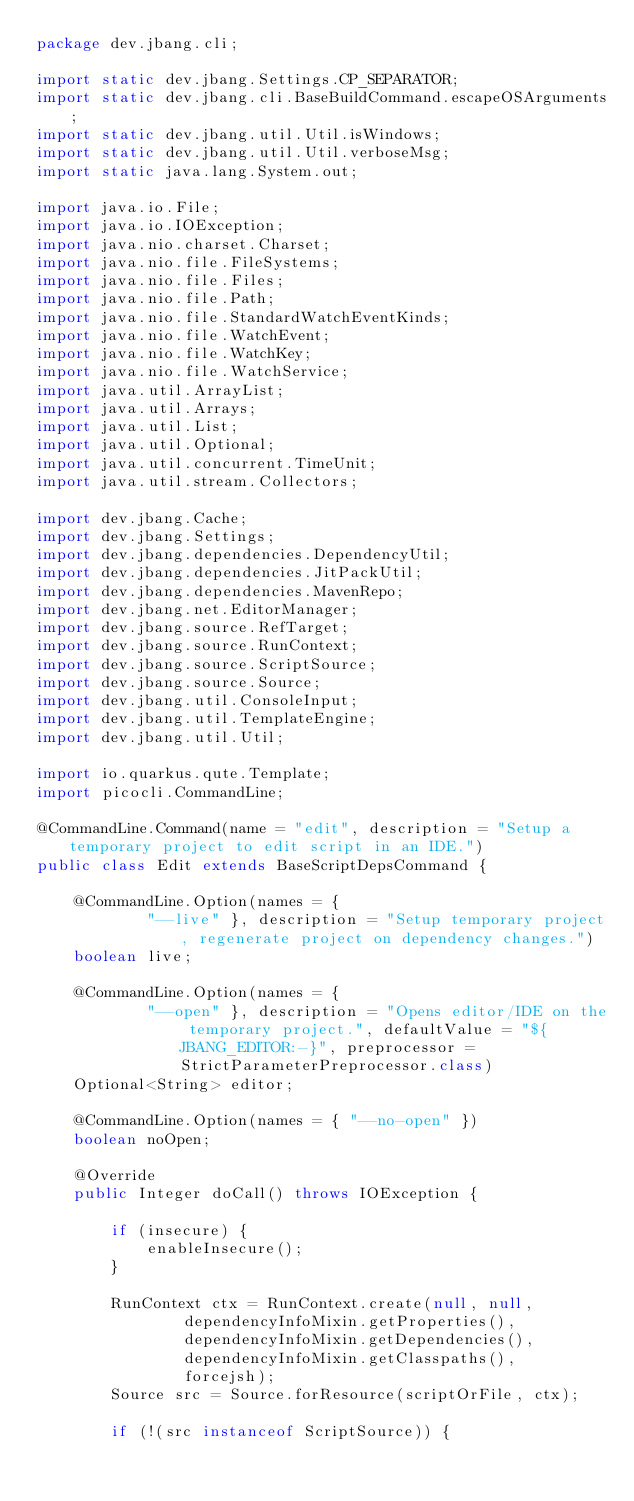Convert code to text. <code><loc_0><loc_0><loc_500><loc_500><_Java_>package dev.jbang.cli;

import static dev.jbang.Settings.CP_SEPARATOR;
import static dev.jbang.cli.BaseBuildCommand.escapeOSArguments;
import static dev.jbang.util.Util.isWindows;
import static dev.jbang.util.Util.verboseMsg;
import static java.lang.System.out;

import java.io.File;
import java.io.IOException;
import java.nio.charset.Charset;
import java.nio.file.FileSystems;
import java.nio.file.Files;
import java.nio.file.Path;
import java.nio.file.StandardWatchEventKinds;
import java.nio.file.WatchEvent;
import java.nio.file.WatchKey;
import java.nio.file.WatchService;
import java.util.ArrayList;
import java.util.Arrays;
import java.util.List;
import java.util.Optional;
import java.util.concurrent.TimeUnit;
import java.util.stream.Collectors;

import dev.jbang.Cache;
import dev.jbang.Settings;
import dev.jbang.dependencies.DependencyUtil;
import dev.jbang.dependencies.JitPackUtil;
import dev.jbang.dependencies.MavenRepo;
import dev.jbang.net.EditorManager;
import dev.jbang.source.RefTarget;
import dev.jbang.source.RunContext;
import dev.jbang.source.ScriptSource;
import dev.jbang.source.Source;
import dev.jbang.util.ConsoleInput;
import dev.jbang.util.TemplateEngine;
import dev.jbang.util.Util;

import io.quarkus.qute.Template;
import picocli.CommandLine;

@CommandLine.Command(name = "edit", description = "Setup a temporary project to edit script in an IDE.")
public class Edit extends BaseScriptDepsCommand {

	@CommandLine.Option(names = {
			"--live" }, description = "Setup temporary project, regenerate project on dependency changes.")
	boolean live;

	@CommandLine.Option(names = {
			"--open" }, description = "Opens editor/IDE on the temporary project.", defaultValue = "${JBANG_EDITOR:-}", preprocessor = StrictParameterPreprocessor.class)
	Optional<String> editor;

	@CommandLine.Option(names = { "--no-open" })
	boolean noOpen;

	@Override
	public Integer doCall() throws IOException {

		if (insecure) {
			enableInsecure();
		}

		RunContext ctx = RunContext.create(null, null,
				dependencyInfoMixin.getProperties(),
				dependencyInfoMixin.getDependencies(),
				dependencyInfoMixin.getClasspaths(),
				forcejsh);
		Source src = Source.forResource(scriptOrFile, ctx);

		if (!(src instanceof ScriptSource)) {</code> 